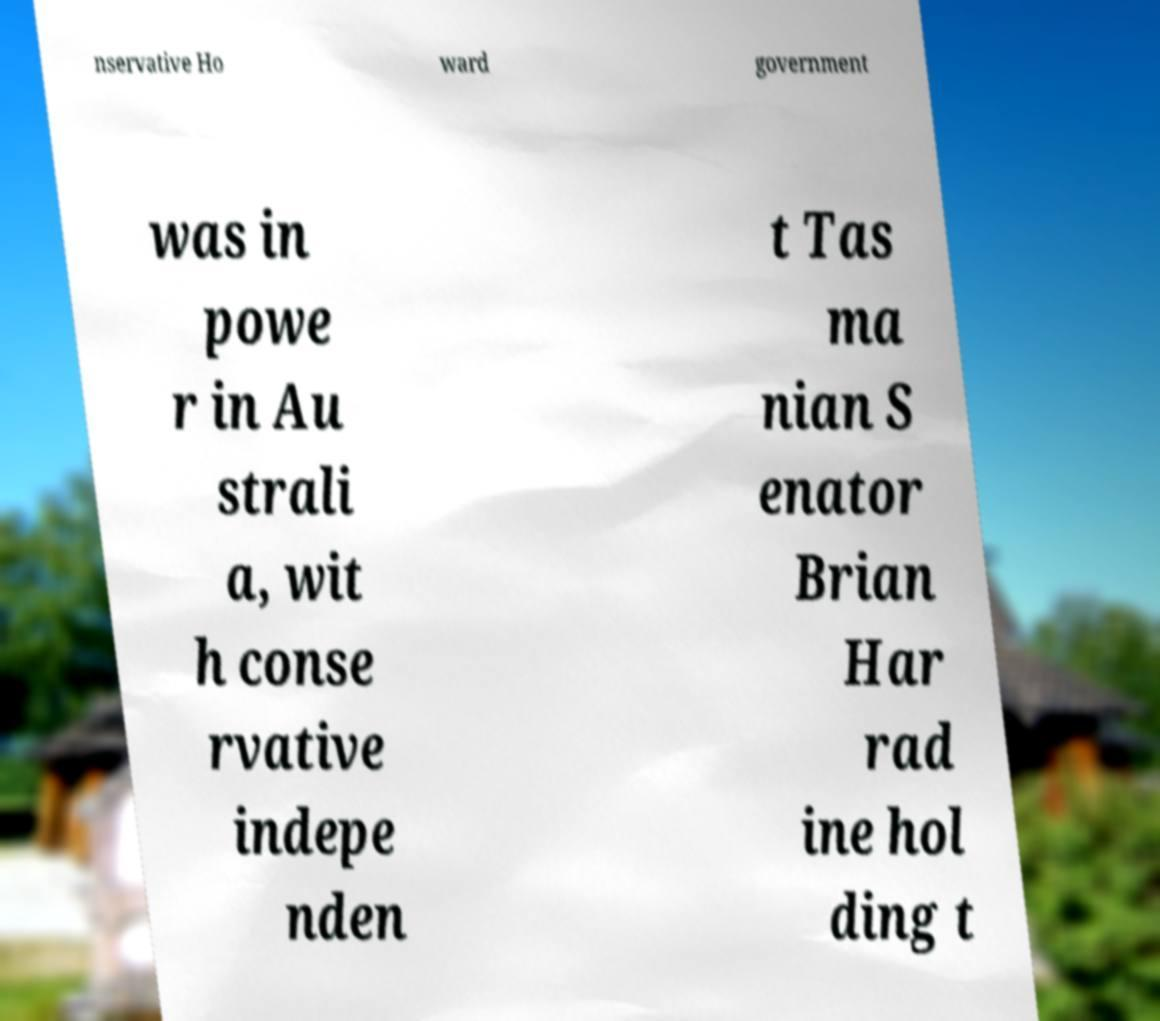Please read and relay the text visible in this image. What does it say? nservative Ho ward government was in powe r in Au strali a, wit h conse rvative indepe nden t Tas ma nian S enator Brian Har rad ine hol ding t 